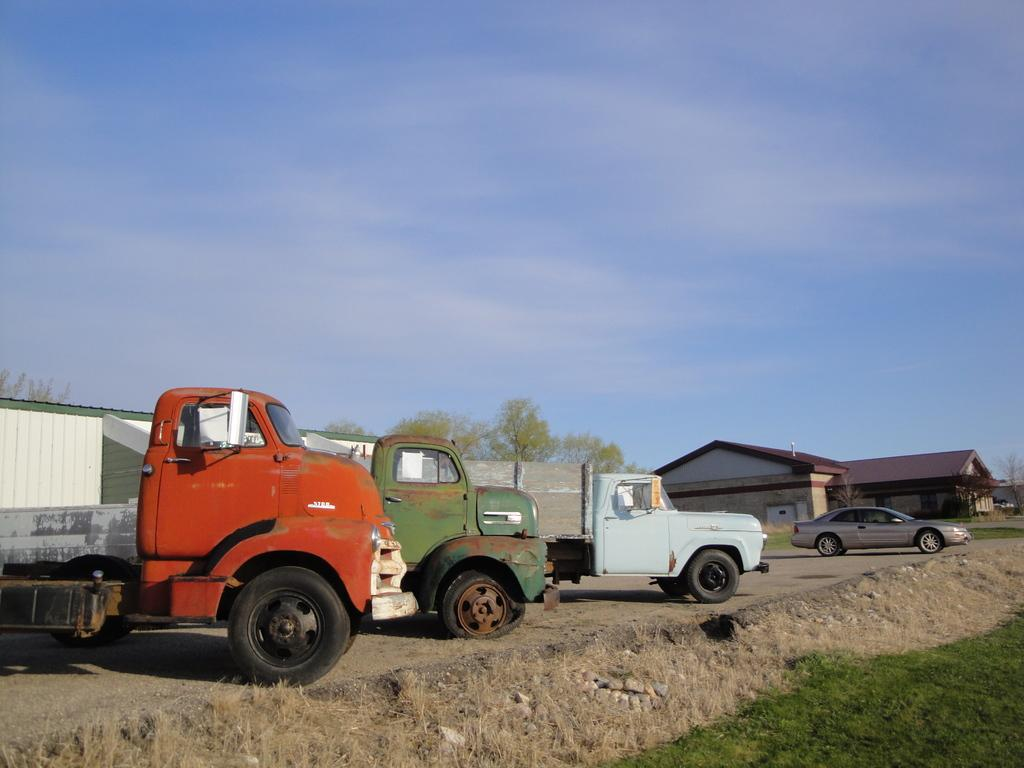What types of objects can be seen in the image? There are vehicles in the image. What can be seen on the ground in the image? The ground is visible in the vehicles are on is visible in the image. What type of vegetation is present in the image? There is grass and trees in the image. What type of structures can be seen in the image? There are houses in the image. What is the background of the image? There is a wall and the sky visible in the image. What is the condition of the sky in the image? The sky is visible in the image, and clouds are present. What type of creature can be seen sitting on the desk in the image? There is no desk present in the image, and therefore no creature can be seen sitting on it. 